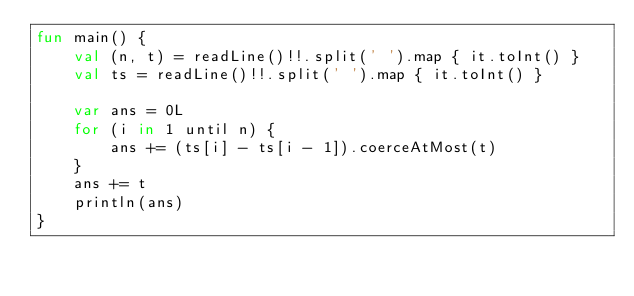<code> <loc_0><loc_0><loc_500><loc_500><_Kotlin_>fun main() {
    val (n, t) = readLine()!!.split(' ').map { it.toInt() }
    val ts = readLine()!!.split(' ').map { it.toInt() }

    var ans = 0L
    for (i in 1 until n) {
        ans += (ts[i] - ts[i - 1]).coerceAtMost(t)
    }
    ans += t
    println(ans)
}
</code> 